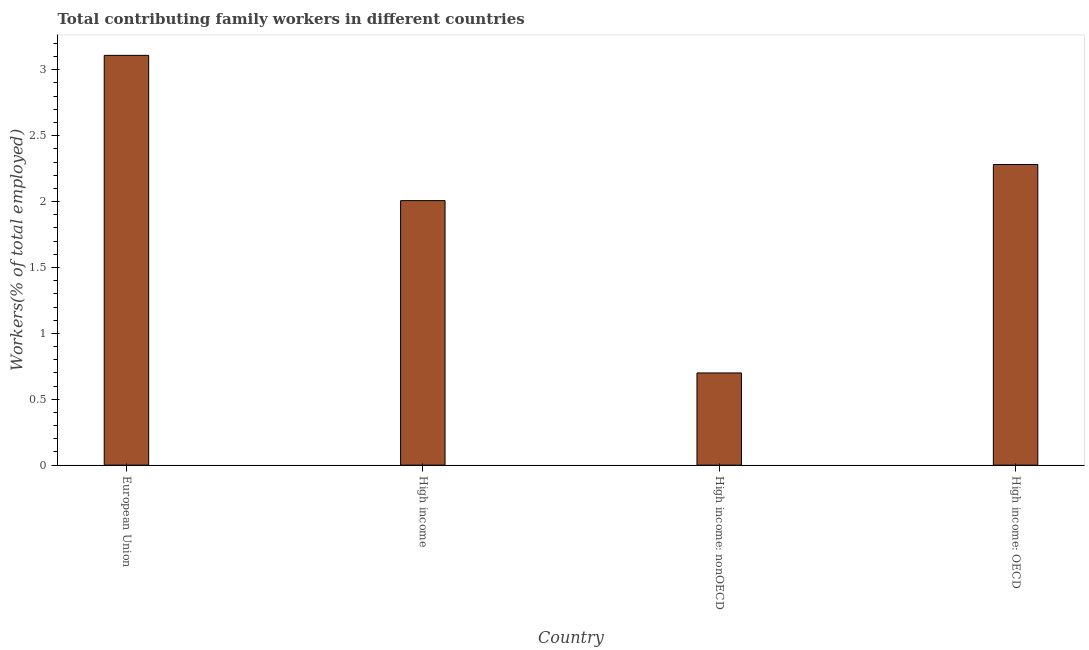Does the graph contain any zero values?
Keep it short and to the point. No. Does the graph contain grids?
Keep it short and to the point. No. What is the title of the graph?
Your response must be concise. Total contributing family workers in different countries. What is the label or title of the X-axis?
Make the answer very short. Country. What is the label or title of the Y-axis?
Your answer should be compact. Workers(% of total employed). What is the contributing family workers in High income: OECD?
Your answer should be very brief. 2.28. Across all countries, what is the maximum contributing family workers?
Provide a short and direct response. 3.11. Across all countries, what is the minimum contributing family workers?
Ensure brevity in your answer.  0.7. In which country was the contributing family workers maximum?
Give a very brief answer. European Union. In which country was the contributing family workers minimum?
Offer a terse response. High income: nonOECD. What is the sum of the contributing family workers?
Give a very brief answer. 8.1. What is the difference between the contributing family workers in High income: OECD and High income: nonOECD?
Give a very brief answer. 1.58. What is the average contributing family workers per country?
Give a very brief answer. 2.02. What is the median contributing family workers?
Provide a succinct answer. 2.14. What is the ratio of the contributing family workers in European Union to that in High income: OECD?
Provide a short and direct response. 1.36. Is the difference between the contributing family workers in European Union and High income: OECD greater than the difference between any two countries?
Your response must be concise. No. What is the difference between the highest and the second highest contributing family workers?
Your answer should be very brief. 0.83. Is the sum of the contributing family workers in High income and High income: nonOECD greater than the maximum contributing family workers across all countries?
Offer a terse response. No. What is the difference between the highest and the lowest contributing family workers?
Offer a very short reply. 2.41. In how many countries, is the contributing family workers greater than the average contributing family workers taken over all countries?
Ensure brevity in your answer.  2. How many bars are there?
Give a very brief answer. 4. What is the difference between two consecutive major ticks on the Y-axis?
Offer a very short reply. 0.5. What is the Workers(% of total employed) in European Union?
Offer a terse response. 3.11. What is the Workers(% of total employed) in High income?
Offer a very short reply. 2.01. What is the Workers(% of total employed) of High income: nonOECD?
Offer a terse response. 0.7. What is the Workers(% of total employed) in High income: OECD?
Give a very brief answer. 2.28. What is the difference between the Workers(% of total employed) in European Union and High income?
Make the answer very short. 1.1. What is the difference between the Workers(% of total employed) in European Union and High income: nonOECD?
Your answer should be very brief. 2.41. What is the difference between the Workers(% of total employed) in European Union and High income: OECD?
Your answer should be very brief. 0.83. What is the difference between the Workers(% of total employed) in High income and High income: nonOECD?
Your response must be concise. 1.31. What is the difference between the Workers(% of total employed) in High income and High income: OECD?
Ensure brevity in your answer.  -0.27. What is the difference between the Workers(% of total employed) in High income: nonOECD and High income: OECD?
Ensure brevity in your answer.  -1.58. What is the ratio of the Workers(% of total employed) in European Union to that in High income?
Your answer should be compact. 1.55. What is the ratio of the Workers(% of total employed) in European Union to that in High income: nonOECD?
Give a very brief answer. 4.44. What is the ratio of the Workers(% of total employed) in European Union to that in High income: OECD?
Provide a succinct answer. 1.36. What is the ratio of the Workers(% of total employed) in High income to that in High income: nonOECD?
Your response must be concise. 2.87. What is the ratio of the Workers(% of total employed) in High income: nonOECD to that in High income: OECD?
Offer a terse response. 0.31. 